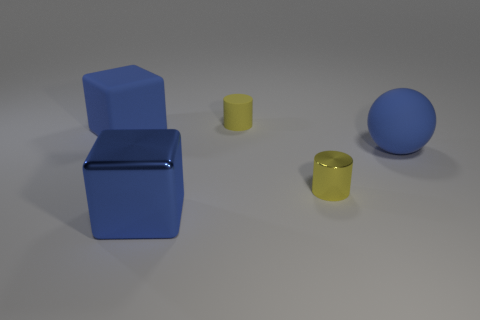Is there any other thing that is the same size as the yellow metal object?
Make the answer very short. Yes. What number of shiny objects are either small yellow objects or blue cubes?
Make the answer very short. 2. Are there any large matte objects?
Give a very brief answer. Yes. The cube that is on the left side of the cube that is in front of the large blue sphere is what color?
Keep it short and to the point. Blue. How many other things are the same color as the sphere?
Provide a short and direct response. 2. What number of objects are either small purple metal cylinders or small objects that are behind the tiny metal thing?
Provide a short and direct response. 1. The small cylinder that is behind the metallic cylinder is what color?
Your response must be concise. Yellow. What is the shape of the big blue metal object?
Ensure brevity in your answer.  Cube. What material is the large block that is behind the sphere behind the metal cylinder?
Offer a terse response. Rubber. What number of other objects are there of the same material as the large blue sphere?
Give a very brief answer. 2. 